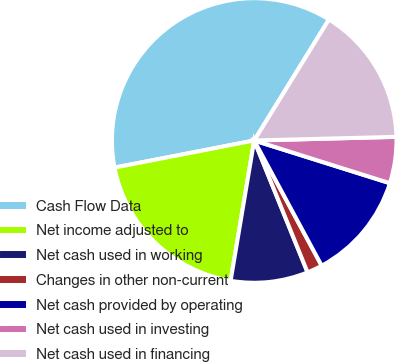<chart> <loc_0><loc_0><loc_500><loc_500><pie_chart><fcel>Cash Flow Data<fcel>Net income adjusted to<fcel>Net cash used in working<fcel>Changes in other non-current<fcel>Net cash provided by operating<fcel>Net cash used in investing<fcel>Net cash used in financing<nl><fcel>36.86%<fcel>19.3%<fcel>8.77%<fcel>1.75%<fcel>12.28%<fcel>5.26%<fcel>15.79%<nl></chart> 